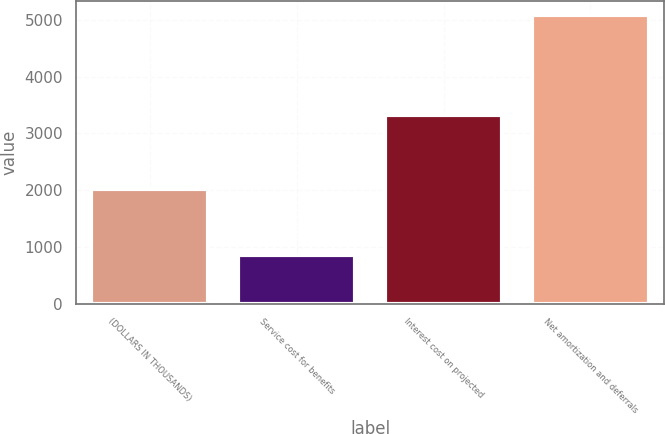<chart> <loc_0><loc_0><loc_500><loc_500><bar_chart><fcel>(DOLLARS IN THOUSANDS)<fcel>Service cost for benefits<fcel>Interest cost on projected<fcel>Net amortization and deferrals<nl><fcel>2016<fcel>852<fcel>3326<fcel>5088<nl></chart> 